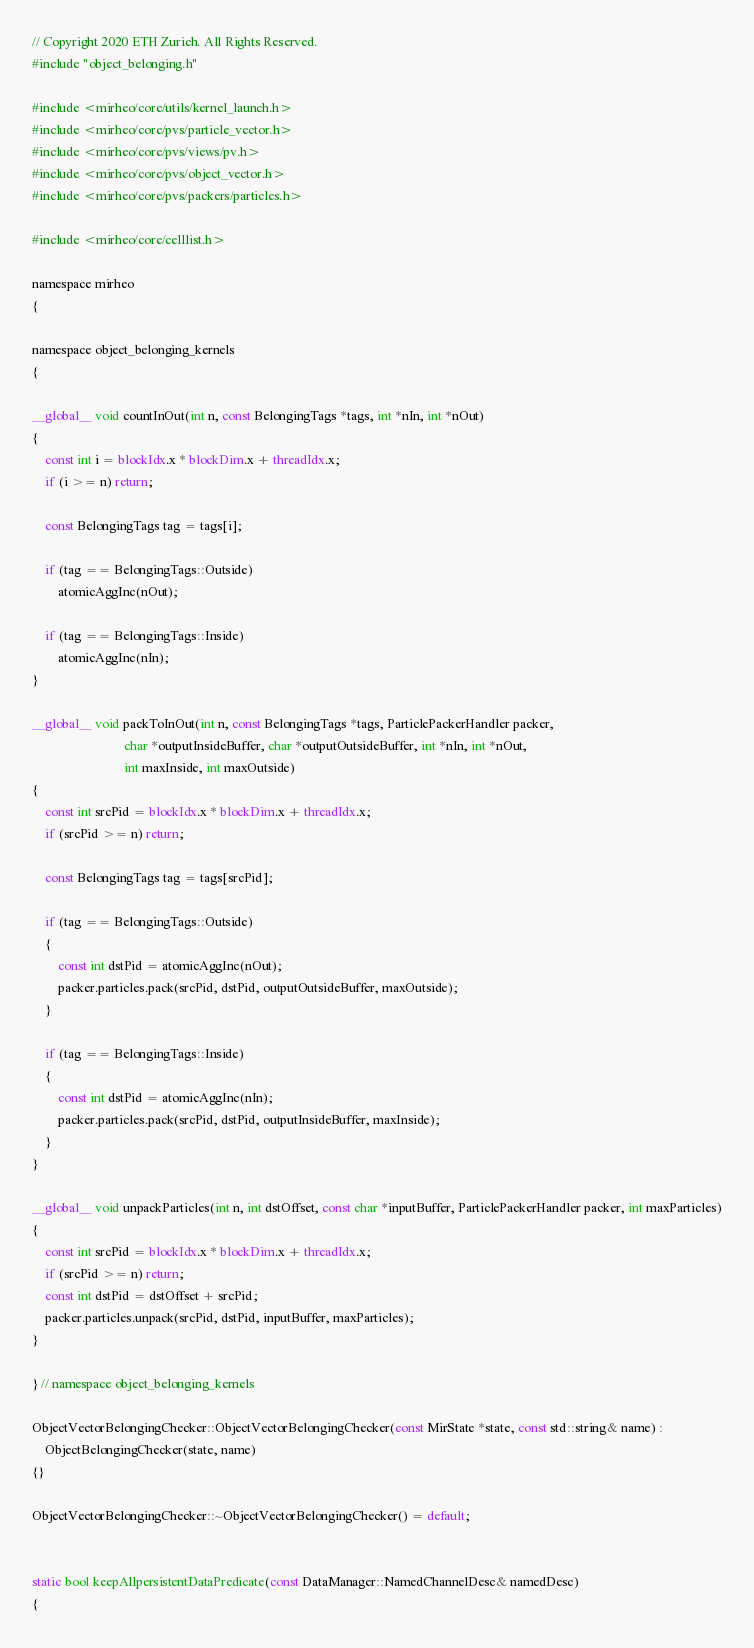Convert code to text. <code><loc_0><loc_0><loc_500><loc_500><_Cuda_>// Copyright 2020 ETH Zurich. All Rights Reserved.
#include "object_belonging.h"

#include <mirheo/core/utils/kernel_launch.h>
#include <mirheo/core/pvs/particle_vector.h>
#include <mirheo/core/pvs/views/pv.h>
#include <mirheo/core/pvs/object_vector.h>
#include <mirheo/core/pvs/packers/particles.h>

#include <mirheo/core/celllist.h>

namespace mirheo
{

namespace object_belonging_kernels
{

__global__ void countInOut(int n, const BelongingTags *tags, int *nIn, int *nOut)
{
    const int i = blockIdx.x * blockDim.x + threadIdx.x;
    if (i >= n) return;

    const BelongingTags tag = tags[i];

    if (tag == BelongingTags::Outside)
        atomicAggInc(nOut);

    if (tag == BelongingTags::Inside)
        atomicAggInc(nIn);
}

__global__ void packToInOut(int n, const BelongingTags *tags, ParticlePackerHandler packer,
                            char *outputInsideBuffer, char *outputOutsideBuffer, int *nIn, int *nOut,
                            int maxInside, int maxOutside)
{
    const int srcPid = blockIdx.x * blockDim.x + threadIdx.x;
    if (srcPid >= n) return;

    const BelongingTags tag = tags[srcPid];

    if (tag == BelongingTags::Outside)
    {
        const int dstPid = atomicAggInc(nOut);
        packer.particles.pack(srcPid, dstPid, outputOutsideBuffer, maxOutside);
    }

    if (tag == BelongingTags::Inside)
    {
        const int dstPid = atomicAggInc(nIn);
        packer.particles.pack(srcPid, dstPid, outputInsideBuffer, maxInside);
    }
}

__global__ void unpackParticles(int n, int dstOffset, const char *inputBuffer, ParticlePackerHandler packer, int maxParticles)
{
    const int srcPid = blockIdx.x * blockDim.x + threadIdx.x;
    if (srcPid >= n) return;
    const int dstPid = dstOffset + srcPid;
    packer.particles.unpack(srcPid, dstPid, inputBuffer, maxParticles);
}

} // namespace object_belonging_kernels

ObjectVectorBelongingChecker::ObjectVectorBelongingChecker(const MirState *state, const std::string& name) :
    ObjectBelongingChecker(state, name)
{}

ObjectVectorBelongingChecker::~ObjectVectorBelongingChecker() = default;


static bool keepAllpersistentDataPredicate(const DataManager::NamedChannelDesc& namedDesc)
{</code> 